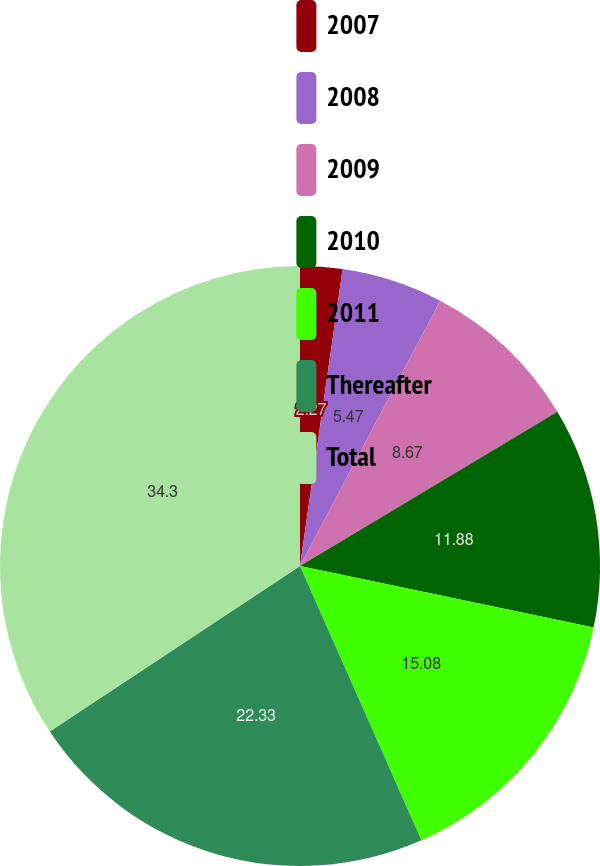Convert chart. <chart><loc_0><loc_0><loc_500><loc_500><pie_chart><fcel>2007<fcel>2008<fcel>2009<fcel>2010<fcel>2011<fcel>Thereafter<fcel>Total<nl><fcel>2.27%<fcel>5.47%<fcel>8.67%<fcel>11.88%<fcel>15.08%<fcel>22.33%<fcel>34.3%<nl></chart> 